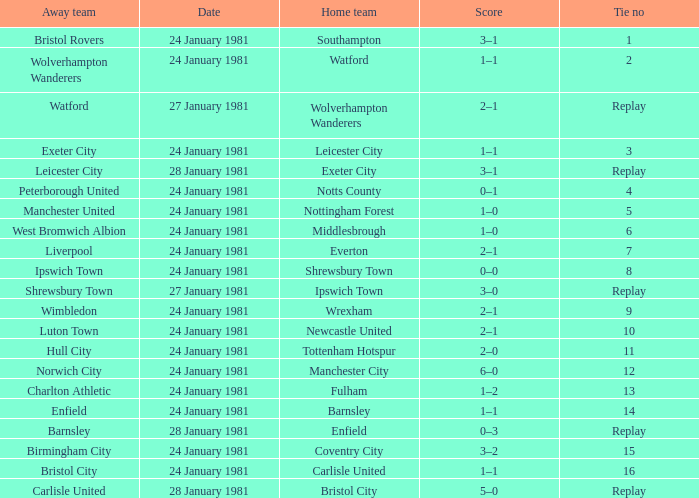What is the score when the tie is 9? 2–1. 